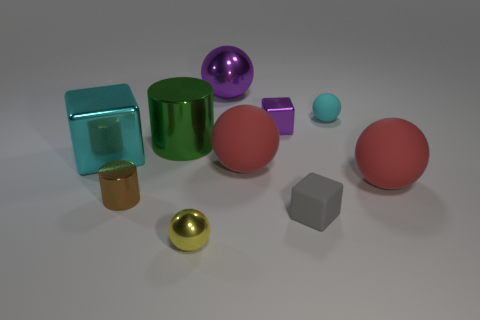What is the color of the tiny shiny object that is behind the large red rubber ball that is behind the big sphere that is right of the tiny gray object?
Give a very brief answer. Purple. How many cyan spheres are to the left of the purple thing that is on the right side of the big metallic object that is to the right of the tiny metallic ball?
Provide a succinct answer. 0. Is there any other thing that is the same color as the tiny cylinder?
Offer a terse response. No. There is a purple object behind the purple shiny block; does it have the same size as the matte cube?
Offer a terse response. No. There is a small thing that is on the left side of the yellow sphere; what number of tiny gray things are behind it?
Your response must be concise. 0. Is there a purple metallic sphere in front of the red ball left of the small metallic object behind the brown cylinder?
Provide a short and direct response. No. There is another object that is the same shape as the brown metal object; what material is it?
Give a very brief answer. Metal. Are there any other things that are made of the same material as the green thing?
Offer a very short reply. Yes. Is the tiny gray block made of the same material as the ball that is in front of the gray rubber cube?
Offer a very short reply. No. There is a tiny shiny object to the right of the metal sphere that is on the right side of the small yellow shiny ball; what is its shape?
Make the answer very short. Cube. 